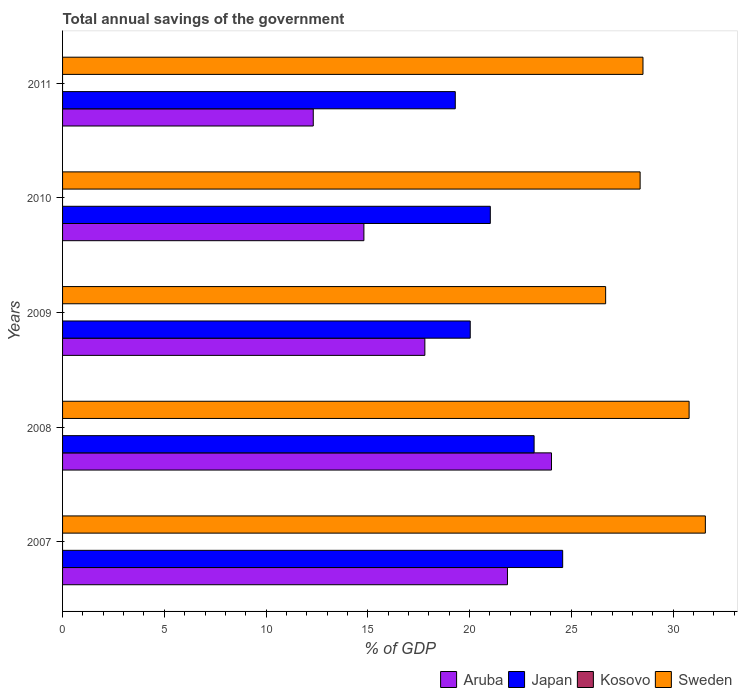How many groups of bars are there?
Your response must be concise. 5. Are the number of bars per tick equal to the number of legend labels?
Provide a succinct answer. No. How many bars are there on the 4th tick from the bottom?
Offer a very short reply. 3. What is the total annual savings of the government in Japan in 2007?
Keep it short and to the point. 24.57. Across all years, what is the maximum total annual savings of the government in Sweden?
Give a very brief answer. 31.59. Across all years, what is the minimum total annual savings of the government in Aruba?
Provide a succinct answer. 12.32. In which year was the total annual savings of the government in Japan maximum?
Your answer should be very brief. 2007. What is the total total annual savings of the government in Aruba in the graph?
Offer a very short reply. 90.81. What is the difference between the total annual savings of the government in Aruba in 2007 and that in 2008?
Keep it short and to the point. -2.16. What is the difference between the total annual savings of the government in Aruba in 2009 and the total annual savings of the government in Japan in 2008?
Ensure brevity in your answer.  -5.37. What is the average total annual savings of the government in Japan per year?
Provide a succinct answer. 21.62. In the year 2011, what is the difference between the total annual savings of the government in Aruba and total annual savings of the government in Japan?
Keep it short and to the point. -6.98. What is the ratio of the total annual savings of the government in Aruba in 2008 to that in 2009?
Offer a very short reply. 1.35. What is the difference between the highest and the second highest total annual savings of the government in Sweden?
Offer a very short reply. 0.8. What is the difference between the highest and the lowest total annual savings of the government in Aruba?
Offer a terse response. 11.71. In how many years, is the total annual savings of the government in Japan greater than the average total annual savings of the government in Japan taken over all years?
Provide a succinct answer. 2. Is the sum of the total annual savings of the government in Aruba in 2008 and 2009 greater than the maximum total annual savings of the government in Sweden across all years?
Provide a short and direct response. Yes. Is it the case that in every year, the sum of the total annual savings of the government in Japan and total annual savings of the government in Aruba is greater than the sum of total annual savings of the government in Sweden and total annual savings of the government in Kosovo?
Provide a short and direct response. No. How many bars are there?
Give a very brief answer. 15. How many years are there in the graph?
Give a very brief answer. 5. What is the difference between two consecutive major ticks on the X-axis?
Give a very brief answer. 5. What is the title of the graph?
Provide a succinct answer. Total annual savings of the government. What is the label or title of the X-axis?
Make the answer very short. % of GDP. What is the label or title of the Y-axis?
Provide a short and direct response. Years. What is the % of GDP of Aruba in 2007?
Provide a succinct answer. 21.86. What is the % of GDP of Japan in 2007?
Keep it short and to the point. 24.57. What is the % of GDP of Kosovo in 2007?
Your answer should be very brief. 0. What is the % of GDP of Sweden in 2007?
Provide a succinct answer. 31.59. What is the % of GDP in Aruba in 2008?
Provide a short and direct response. 24.02. What is the % of GDP in Japan in 2008?
Provide a succinct answer. 23.17. What is the % of GDP in Kosovo in 2008?
Give a very brief answer. 0. What is the % of GDP of Sweden in 2008?
Keep it short and to the point. 30.79. What is the % of GDP of Aruba in 2009?
Keep it short and to the point. 17.8. What is the % of GDP in Japan in 2009?
Provide a succinct answer. 20.03. What is the % of GDP of Kosovo in 2009?
Provide a short and direct response. 0. What is the % of GDP of Sweden in 2009?
Make the answer very short. 26.69. What is the % of GDP in Aruba in 2010?
Your answer should be compact. 14.81. What is the % of GDP of Japan in 2010?
Give a very brief answer. 21.02. What is the % of GDP in Kosovo in 2010?
Offer a terse response. 0. What is the % of GDP of Sweden in 2010?
Ensure brevity in your answer.  28.38. What is the % of GDP of Aruba in 2011?
Ensure brevity in your answer.  12.32. What is the % of GDP of Japan in 2011?
Make the answer very short. 19.3. What is the % of GDP of Kosovo in 2011?
Provide a short and direct response. 0. What is the % of GDP in Sweden in 2011?
Provide a short and direct response. 28.52. Across all years, what is the maximum % of GDP in Aruba?
Provide a succinct answer. 24.02. Across all years, what is the maximum % of GDP in Japan?
Provide a succinct answer. 24.57. Across all years, what is the maximum % of GDP of Sweden?
Make the answer very short. 31.59. Across all years, what is the minimum % of GDP in Aruba?
Your answer should be compact. 12.32. Across all years, what is the minimum % of GDP of Japan?
Provide a succinct answer. 19.3. Across all years, what is the minimum % of GDP in Sweden?
Keep it short and to the point. 26.69. What is the total % of GDP of Aruba in the graph?
Your response must be concise. 90.81. What is the total % of GDP of Japan in the graph?
Make the answer very short. 108.09. What is the total % of GDP of Sweden in the graph?
Your answer should be very brief. 145.96. What is the difference between the % of GDP in Aruba in 2007 and that in 2008?
Your answer should be very brief. -2.16. What is the difference between the % of GDP of Japan in 2007 and that in 2008?
Make the answer very short. 1.4. What is the difference between the % of GDP in Sweden in 2007 and that in 2008?
Your response must be concise. 0.8. What is the difference between the % of GDP of Aruba in 2007 and that in 2009?
Make the answer very short. 4.06. What is the difference between the % of GDP of Japan in 2007 and that in 2009?
Provide a short and direct response. 4.54. What is the difference between the % of GDP in Sweden in 2007 and that in 2009?
Your answer should be compact. 4.9. What is the difference between the % of GDP of Aruba in 2007 and that in 2010?
Offer a terse response. 7.05. What is the difference between the % of GDP of Japan in 2007 and that in 2010?
Provide a short and direct response. 3.56. What is the difference between the % of GDP in Sweden in 2007 and that in 2010?
Provide a succinct answer. 3.21. What is the difference between the % of GDP in Aruba in 2007 and that in 2011?
Offer a terse response. 9.54. What is the difference between the % of GDP of Japan in 2007 and that in 2011?
Offer a terse response. 5.28. What is the difference between the % of GDP of Sweden in 2007 and that in 2011?
Offer a very short reply. 3.06. What is the difference between the % of GDP of Aruba in 2008 and that in 2009?
Offer a very short reply. 6.22. What is the difference between the % of GDP in Japan in 2008 and that in 2009?
Your answer should be very brief. 3.14. What is the difference between the % of GDP of Sweden in 2008 and that in 2009?
Offer a very short reply. 4.1. What is the difference between the % of GDP in Aruba in 2008 and that in 2010?
Ensure brevity in your answer.  9.22. What is the difference between the % of GDP in Japan in 2008 and that in 2010?
Ensure brevity in your answer.  2.15. What is the difference between the % of GDP in Sweden in 2008 and that in 2010?
Give a very brief answer. 2.41. What is the difference between the % of GDP of Aruba in 2008 and that in 2011?
Make the answer very short. 11.71. What is the difference between the % of GDP in Japan in 2008 and that in 2011?
Ensure brevity in your answer.  3.87. What is the difference between the % of GDP of Sweden in 2008 and that in 2011?
Give a very brief answer. 2.27. What is the difference between the % of GDP in Aruba in 2009 and that in 2010?
Ensure brevity in your answer.  3. What is the difference between the % of GDP in Japan in 2009 and that in 2010?
Give a very brief answer. -0.99. What is the difference between the % of GDP in Sweden in 2009 and that in 2010?
Give a very brief answer. -1.69. What is the difference between the % of GDP in Aruba in 2009 and that in 2011?
Give a very brief answer. 5.48. What is the difference between the % of GDP in Japan in 2009 and that in 2011?
Give a very brief answer. 0.73. What is the difference between the % of GDP in Sweden in 2009 and that in 2011?
Make the answer very short. -1.83. What is the difference between the % of GDP in Aruba in 2010 and that in 2011?
Offer a very short reply. 2.49. What is the difference between the % of GDP in Japan in 2010 and that in 2011?
Offer a very short reply. 1.72. What is the difference between the % of GDP in Sweden in 2010 and that in 2011?
Make the answer very short. -0.14. What is the difference between the % of GDP in Aruba in 2007 and the % of GDP in Japan in 2008?
Your response must be concise. -1.31. What is the difference between the % of GDP in Aruba in 2007 and the % of GDP in Sweden in 2008?
Provide a short and direct response. -8.93. What is the difference between the % of GDP of Japan in 2007 and the % of GDP of Sweden in 2008?
Offer a terse response. -6.21. What is the difference between the % of GDP in Aruba in 2007 and the % of GDP in Japan in 2009?
Provide a short and direct response. 1.83. What is the difference between the % of GDP of Aruba in 2007 and the % of GDP of Sweden in 2009?
Provide a succinct answer. -4.82. What is the difference between the % of GDP of Japan in 2007 and the % of GDP of Sweden in 2009?
Offer a terse response. -2.11. What is the difference between the % of GDP in Aruba in 2007 and the % of GDP in Japan in 2010?
Keep it short and to the point. 0.84. What is the difference between the % of GDP in Aruba in 2007 and the % of GDP in Sweden in 2010?
Your response must be concise. -6.52. What is the difference between the % of GDP in Japan in 2007 and the % of GDP in Sweden in 2010?
Give a very brief answer. -3.81. What is the difference between the % of GDP of Aruba in 2007 and the % of GDP of Japan in 2011?
Offer a very short reply. 2.56. What is the difference between the % of GDP in Aruba in 2007 and the % of GDP in Sweden in 2011?
Provide a short and direct response. -6.66. What is the difference between the % of GDP in Japan in 2007 and the % of GDP in Sweden in 2011?
Provide a succinct answer. -3.95. What is the difference between the % of GDP of Aruba in 2008 and the % of GDP of Japan in 2009?
Your response must be concise. 3.99. What is the difference between the % of GDP in Aruba in 2008 and the % of GDP in Sweden in 2009?
Make the answer very short. -2.66. What is the difference between the % of GDP in Japan in 2008 and the % of GDP in Sweden in 2009?
Provide a succinct answer. -3.51. What is the difference between the % of GDP in Aruba in 2008 and the % of GDP in Japan in 2010?
Provide a short and direct response. 3.01. What is the difference between the % of GDP in Aruba in 2008 and the % of GDP in Sweden in 2010?
Offer a very short reply. -4.36. What is the difference between the % of GDP in Japan in 2008 and the % of GDP in Sweden in 2010?
Your answer should be very brief. -5.21. What is the difference between the % of GDP of Aruba in 2008 and the % of GDP of Japan in 2011?
Offer a very short reply. 4.73. What is the difference between the % of GDP of Aruba in 2008 and the % of GDP of Sweden in 2011?
Provide a short and direct response. -4.5. What is the difference between the % of GDP of Japan in 2008 and the % of GDP of Sweden in 2011?
Offer a terse response. -5.35. What is the difference between the % of GDP of Aruba in 2009 and the % of GDP of Japan in 2010?
Your answer should be compact. -3.22. What is the difference between the % of GDP in Aruba in 2009 and the % of GDP in Sweden in 2010?
Offer a very short reply. -10.58. What is the difference between the % of GDP in Japan in 2009 and the % of GDP in Sweden in 2010?
Offer a terse response. -8.35. What is the difference between the % of GDP in Aruba in 2009 and the % of GDP in Japan in 2011?
Your answer should be very brief. -1.49. What is the difference between the % of GDP of Aruba in 2009 and the % of GDP of Sweden in 2011?
Keep it short and to the point. -10.72. What is the difference between the % of GDP of Japan in 2009 and the % of GDP of Sweden in 2011?
Keep it short and to the point. -8.49. What is the difference between the % of GDP of Aruba in 2010 and the % of GDP of Japan in 2011?
Keep it short and to the point. -4.49. What is the difference between the % of GDP in Aruba in 2010 and the % of GDP in Sweden in 2011?
Provide a succinct answer. -13.71. What is the difference between the % of GDP of Japan in 2010 and the % of GDP of Sweden in 2011?
Offer a very short reply. -7.5. What is the average % of GDP of Aruba per year?
Provide a succinct answer. 18.16. What is the average % of GDP in Japan per year?
Provide a short and direct response. 21.62. What is the average % of GDP of Sweden per year?
Offer a terse response. 29.19. In the year 2007, what is the difference between the % of GDP in Aruba and % of GDP in Japan?
Provide a short and direct response. -2.71. In the year 2007, what is the difference between the % of GDP of Aruba and % of GDP of Sweden?
Your answer should be very brief. -9.72. In the year 2007, what is the difference between the % of GDP of Japan and % of GDP of Sweden?
Give a very brief answer. -7.01. In the year 2008, what is the difference between the % of GDP in Aruba and % of GDP in Japan?
Ensure brevity in your answer.  0.85. In the year 2008, what is the difference between the % of GDP of Aruba and % of GDP of Sweden?
Your response must be concise. -6.76. In the year 2008, what is the difference between the % of GDP of Japan and % of GDP of Sweden?
Provide a succinct answer. -7.62. In the year 2009, what is the difference between the % of GDP of Aruba and % of GDP of Japan?
Your answer should be very brief. -2.23. In the year 2009, what is the difference between the % of GDP of Aruba and % of GDP of Sweden?
Give a very brief answer. -8.88. In the year 2009, what is the difference between the % of GDP of Japan and % of GDP of Sweden?
Provide a succinct answer. -6.65. In the year 2010, what is the difference between the % of GDP in Aruba and % of GDP in Japan?
Provide a succinct answer. -6.21. In the year 2010, what is the difference between the % of GDP in Aruba and % of GDP in Sweden?
Offer a very short reply. -13.57. In the year 2010, what is the difference between the % of GDP in Japan and % of GDP in Sweden?
Offer a terse response. -7.36. In the year 2011, what is the difference between the % of GDP in Aruba and % of GDP in Japan?
Offer a very short reply. -6.98. In the year 2011, what is the difference between the % of GDP of Aruba and % of GDP of Sweden?
Give a very brief answer. -16.2. In the year 2011, what is the difference between the % of GDP of Japan and % of GDP of Sweden?
Your response must be concise. -9.22. What is the ratio of the % of GDP in Aruba in 2007 to that in 2008?
Your response must be concise. 0.91. What is the ratio of the % of GDP in Japan in 2007 to that in 2008?
Ensure brevity in your answer.  1.06. What is the ratio of the % of GDP in Sweden in 2007 to that in 2008?
Ensure brevity in your answer.  1.03. What is the ratio of the % of GDP of Aruba in 2007 to that in 2009?
Ensure brevity in your answer.  1.23. What is the ratio of the % of GDP in Japan in 2007 to that in 2009?
Make the answer very short. 1.23. What is the ratio of the % of GDP in Sweden in 2007 to that in 2009?
Provide a short and direct response. 1.18. What is the ratio of the % of GDP of Aruba in 2007 to that in 2010?
Your response must be concise. 1.48. What is the ratio of the % of GDP in Japan in 2007 to that in 2010?
Keep it short and to the point. 1.17. What is the ratio of the % of GDP in Sweden in 2007 to that in 2010?
Keep it short and to the point. 1.11. What is the ratio of the % of GDP of Aruba in 2007 to that in 2011?
Offer a very short reply. 1.77. What is the ratio of the % of GDP in Japan in 2007 to that in 2011?
Provide a short and direct response. 1.27. What is the ratio of the % of GDP in Sweden in 2007 to that in 2011?
Ensure brevity in your answer.  1.11. What is the ratio of the % of GDP in Aruba in 2008 to that in 2009?
Offer a terse response. 1.35. What is the ratio of the % of GDP in Japan in 2008 to that in 2009?
Your answer should be very brief. 1.16. What is the ratio of the % of GDP of Sweden in 2008 to that in 2009?
Your answer should be very brief. 1.15. What is the ratio of the % of GDP of Aruba in 2008 to that in 2010?
Your answer should be very brief. 1.62. What is the ratio of the % of GDP in Japan in 2008 to that in 2010?
Give a very brief answer. 1.1. What is the ratio of the % of GDP in Sweden in 2008 to that in 2010?
Your answer should be very brief. 1.08. What is the ratio of the % of GDP in Aruba in 2008 to that in 2011?
Your answer should be very brief. 1.95. What is the ratio of the % of GDP in Japan in 2008 to that in 2011?
Keep it short and to the point. 1.2. What is the ratio of the % of GDP of Sweden in 2008 to that in 2011?
Give a very brief answer. 1.08. What is the ratio of the % of GDP in Aruba in 2009 to that in 2010?
Offer a very short reply. 1.2. What is the ratio of the % of GDP of Japan in 2009 to that in 2010?
Give a very brief answer. 0.95. What is the ratio of the % of GDP of Sweden in 2009 to that in 2010?
Provide a short and direct response. 0.94. What is the ratio of the % of GDP of Aruba in 2009 to that in 2011?
Provide a short and direct response. 1.45. What is the ratio of the % of GDP of Japan in 2009 to that in 2011?
Offer a terse response. 1.04. What is the ratio of the % of GDP of Sweden in 2009 to that in 2011?
Make the answer very short. 0.94. What is the ratio of the % of GDP of Aruba in 2010 to that in 2011?
Give a very brief answer. 1.2. What is the ratio of the % of GDP in Japan in 2010 to that in 2011?
Ensure brevity in your answer.  1.09. What is the difference between the highest and the second highest % of GDP in Aruba?
Keep it short and to the point. 2.16. What is the difference between the highest and the second highest % of GDP in Japan?
Provide a succinct answer. 1.4. What is the difference between the highest and the second highest % of GDP of Sweden?
Keep it short and to the point. 0.8. What is the difference between the highest and the lowest % of GDP in Aruba?
Provide a short and direct response. 11.71. What is the difference between the highest and the lowest % of GDP in Japan?
Your answer should be compact. 5.28. What is the difference between the highest and the lowest % of GDP in Sweden?
Provide a short and direct response. 4.9. 